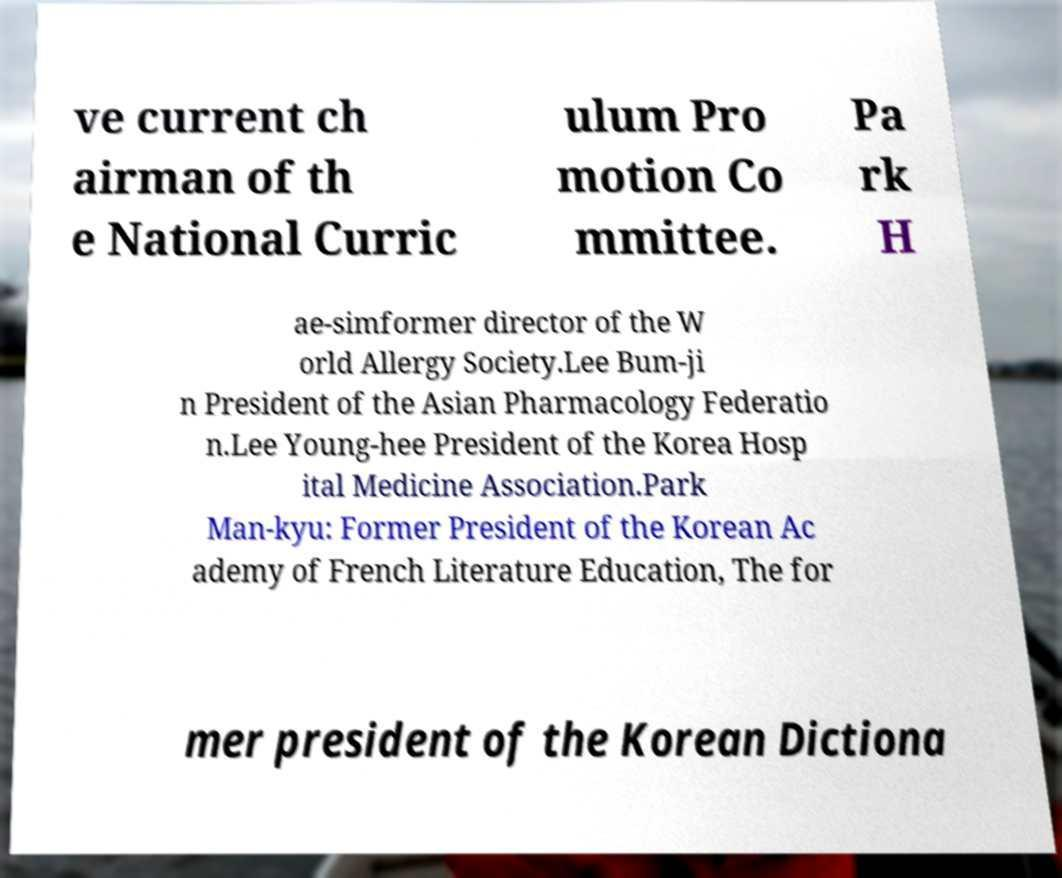Can you read and provide the text displayed in the image?This photo seems to have some interesting text. Can you extract and type it out for me? ve current ch airman of th e National Curric ulum Pro motion Co mmittee. Pa rk H ae-simformer director of the W orld Allergy Society.Lee Bum-ji n President of the Asian Pharmacology Federatio n.Lee Young-hee President of the Korea Hosp ital Medicine Association.Park Man-kyu: Former President of the Korean Ac ademy of French Literature Education, The for mer president of the Korean Dictiona 